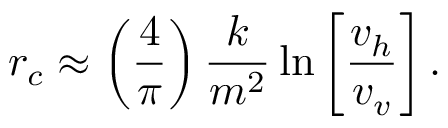<formula> <loc_0><loc_0><loc_500><loc_500>r _ { c } \approx \left ( \frac { 4 } { \pi } \right ) \frac { k } { m ^ { 2 } } \ln \left [ \frac { v _ { h } } { v _ { v } } \right ] .</formula> 